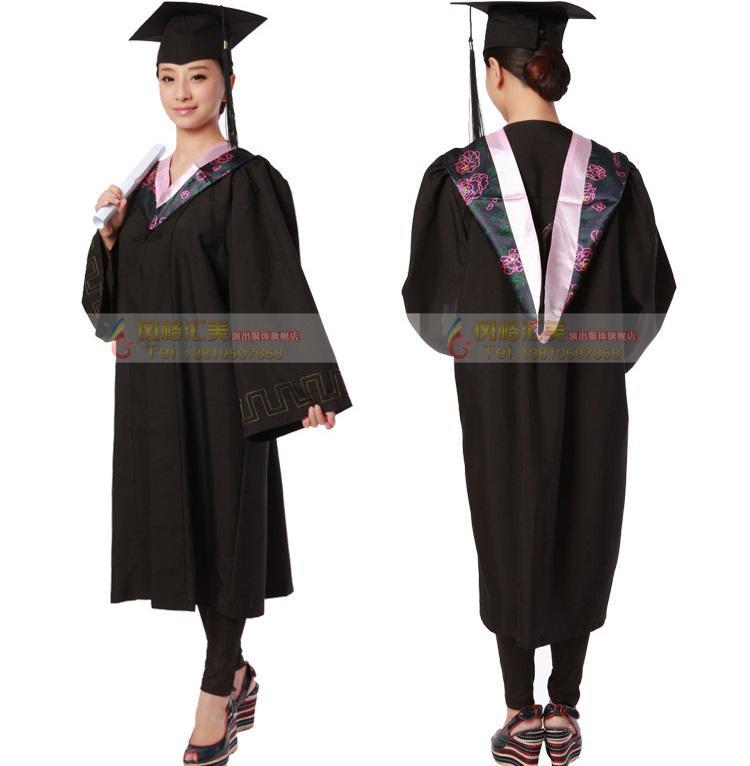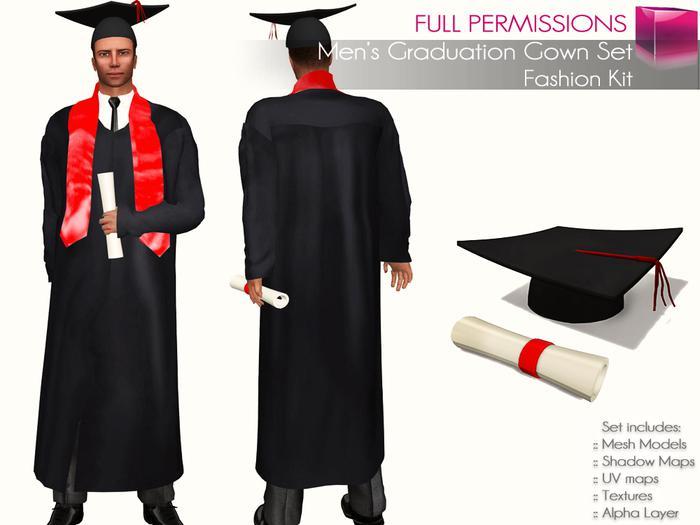The first image is the image on the left, the second image is the image on the right. Given the left and right images, does the statement "There are two views of a person who is where a red sash and black graduation robe." hold true? Answer yes or no. Yes. 